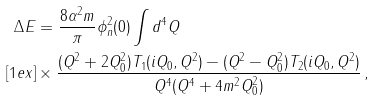Convert formula to latex. <formula><loc_0><loc_0><loc_500><loc_500>\Delta E & = \frac { 8 \alpha ^ { 2 } m } { \pi } \phi ^ { 2 } _ { n } ( 0 ) \int d ^ { 4 } Q \\ [ 1 e x ] & \times \frac { ( Q ^ { 2 } + 2 Q _ { 0 } ^ { 2 } ) T _ { 1 } ( i Q _ { 0 } , Q ^ { 2 } ) - ( Q ^ { 2 } - Q _ { 0 } ^ { 2 } ) T _ { 2 } ( i Q _ { 0 } , Q ^ { 2 } ) } { Q ^ { 4 } ( Q ^ { 4 } + 4 m ^ { 2 } Q _ { 0 } ^ { 2 } ) } \, ,</formula> 